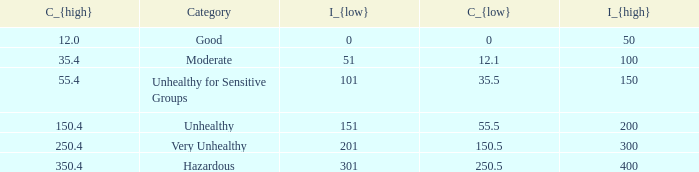In how many different categories is the value of C_{low} 35.5? 1.0. 